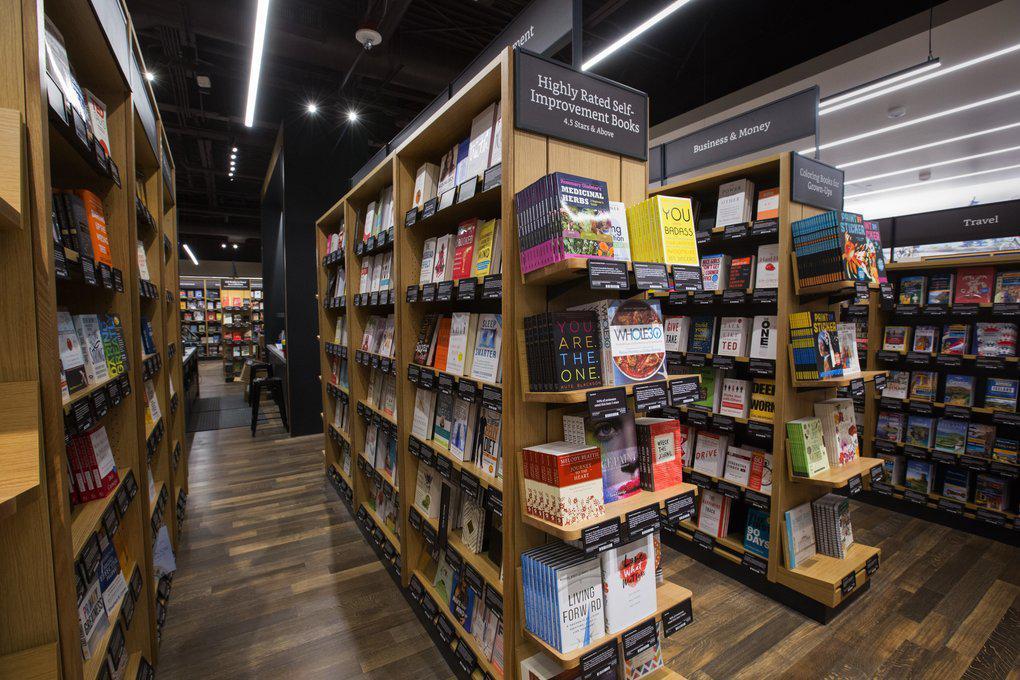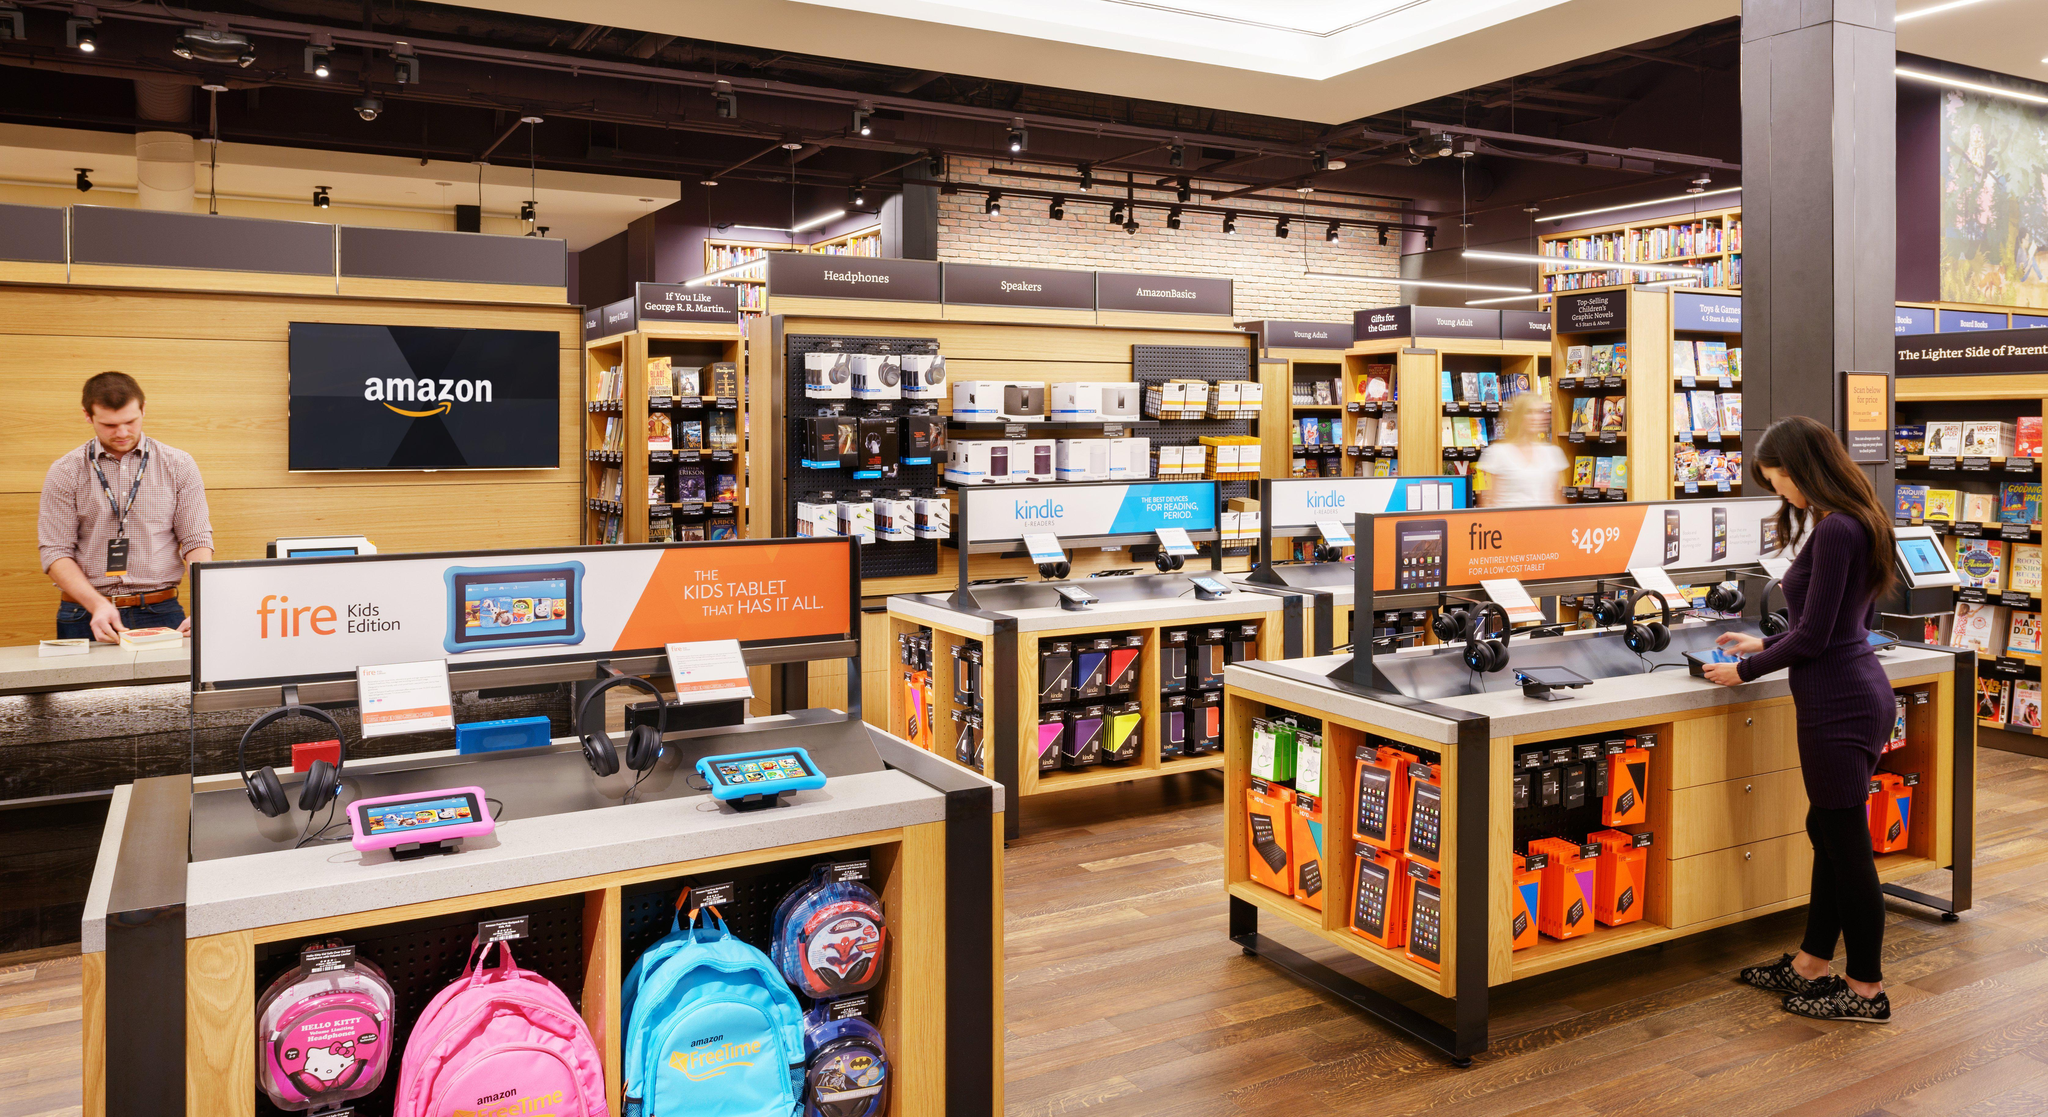The first image is the image on the left, the second image is the image on the right. Examine the images to the left and right. Is the description "There are people looking at books in the bookstore in both images." accurate? Answer yes or no. No. 